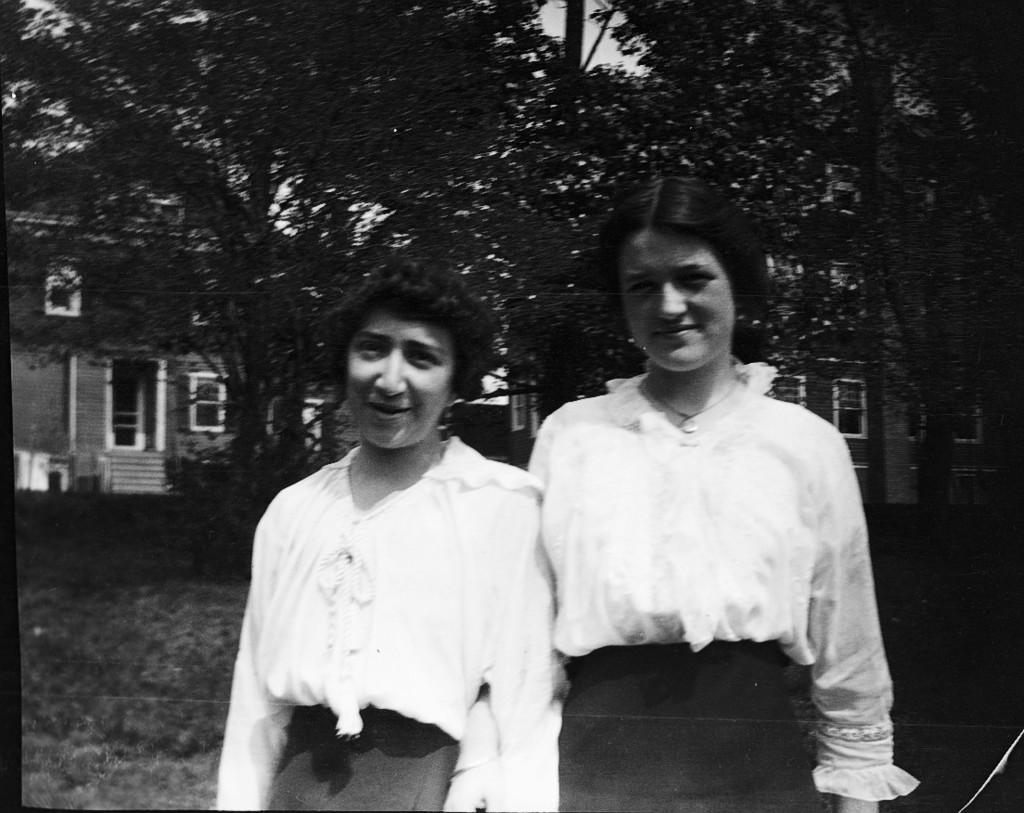How many people are in the image? There are two women standing in the image. What can be seen in the background of the image? There are trees and homes visible in the background of the image. What direction are the women walking in the image? There is no indication of the women walking in the image; they are standing still. 